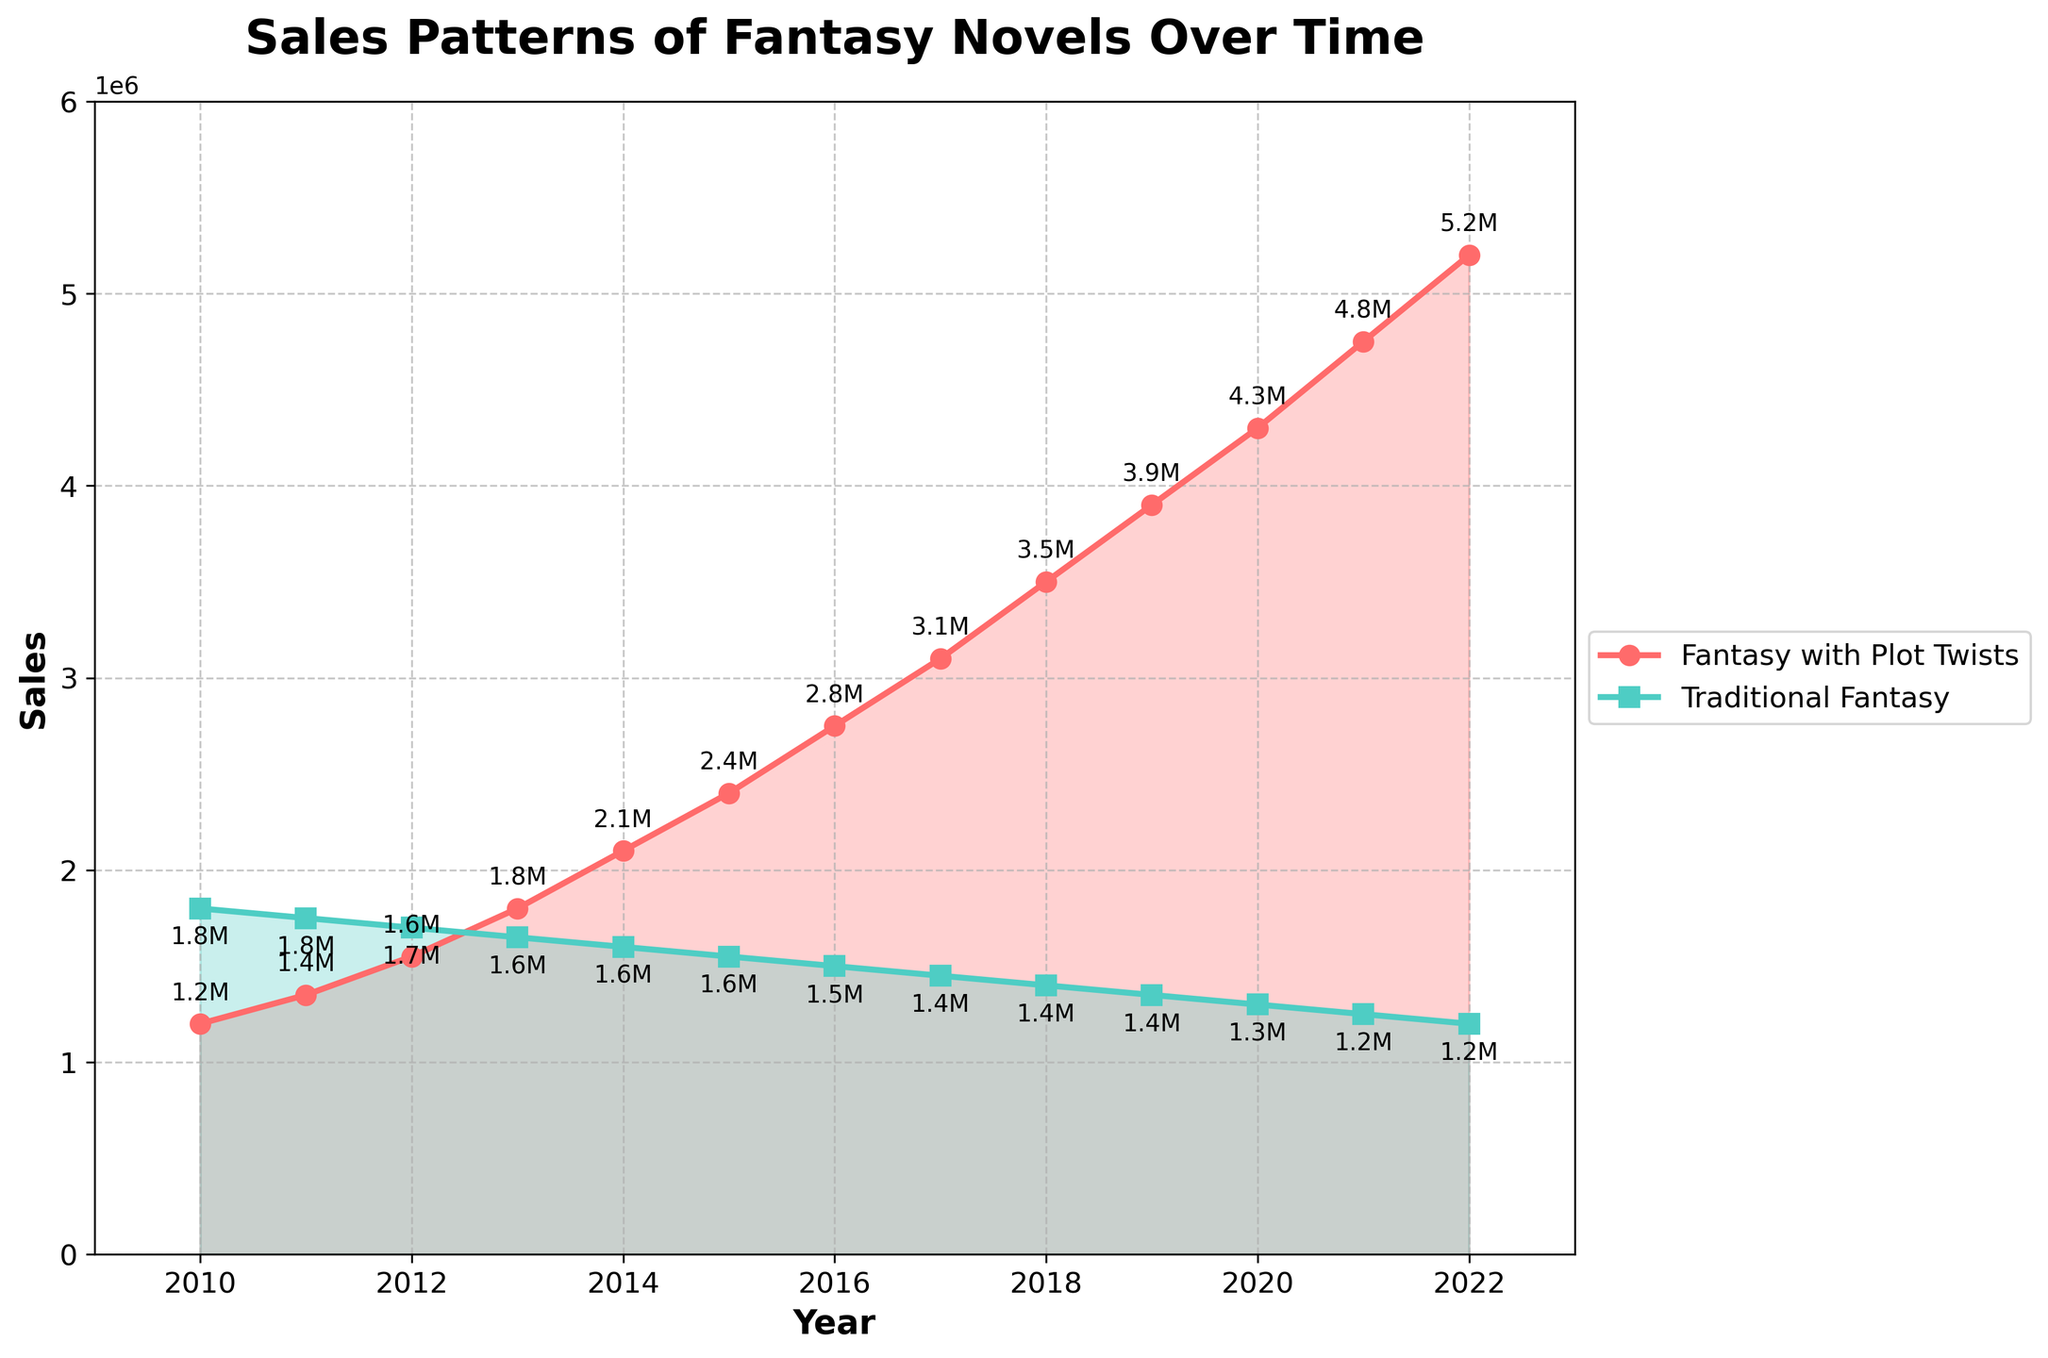Which category had higher sales in 2010? Compare the positions of both lines in 2010, checking the y-axis values. The traditional fantasy line is above the fantasy with plot twists line in this year.
Answer: Traditional Fantasy How much did the sales of traditional fantasy novels decrease from 2010 to 2022? Subtract the 2022 value (1,200,000) from the 2010 value (1,800,000): 1,800,000 - 1,200,000. The reduction is 600,000.
Answer: 600,000 What is the average annual sales growth of fantasy novels with plot twists between 2010 and 2022? Calculate the increase in sales from 2010 (1,200,000) to 2022 (5,200,000), which is 4,000,000, and divide by the number of years (2022-2010=12). The average annual growth is 4,000,000 / 12.
Answer: 333,333.33 Did traditional fantasy novels ever achieve higher sales than fantasy novels with plot twists after 2010? Examine the lines post-2010; the traditional fantasy line starts above but ends below the fantasy with plot twists line.
Answer: No In which year did sales of fantasy novels with plot twists surpass the sales of traditional fantasy novels? Identify the intersection point of both lines on the graph. This occurs around 2013.
Answer: 2013 By how much did the sales of fantasy novels with plot twists exceed traditional fantasy novels in 2022? Subtract the 2022 sales of traditional fantasy novels (1,200,000) from the 2022 sales of fantasy novels with plot twists (5,200,000). The difference is 4,000,000.
Answer: 4,000,000 What is the color representation for each category in the plot? Observe the lines and fill colors: the line representing fantasy novels with plot twists is red, and the line representing traditional fantasy novels is green.
Answer: Red and Green Which category showed the most constant trend over the years? Look at the slopes of both lines; the traditional category shows a more consistent downward trend, whereas the fantasy with plot twists category shows a strong upward trend.
Answer: Traditional Fantasy Between which consecutive years did fantasy novels with plot twists see the highest sales increase? Calculate the year-over-year differences for fantasy novels with plot twists and identify the maximum increase: 5200000-4750000 = 450000 from 2021 to 2022.
Answer: 2021 to 2022 How many years did it take for the sales of fantasy novels with plot twists to double from their 2010 value? Double the 2010 sales of fantasy novels with plot twists (1,200,000 * 2 = 2,400,000) and find the year it reaches this value; which is 2015.
Answer: 5 years 